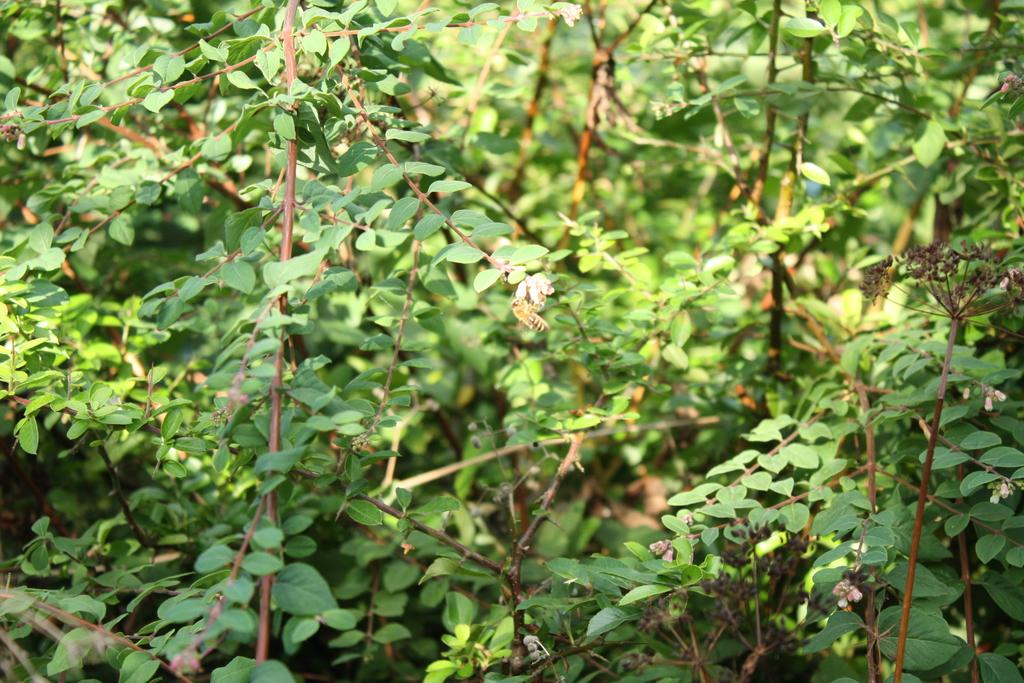What type of vegetation can be seen in the image? There are branches of trees in the image. Can you describe any living organisms present in the image? Yes, there is a honey bee on a flower in the image. What is the reason the woman is spying on the honey bee in the image? There is no woman present in the image, and therefore no spying activity can be observed. 